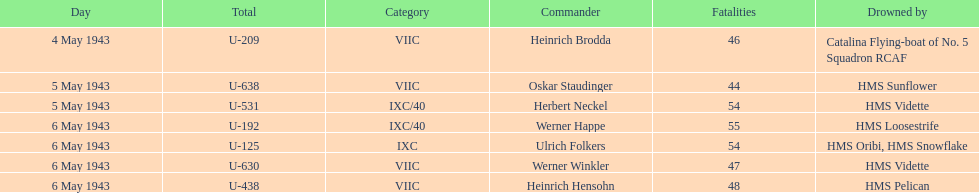What is the only vessel to sink multiple u-boats? HMS Vidette. 